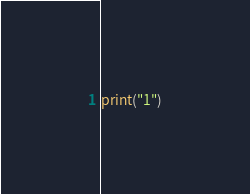Convert code to text. <code><loc_0><loc_0><loc_500><loc_500><_Python_>print("1")</code> 